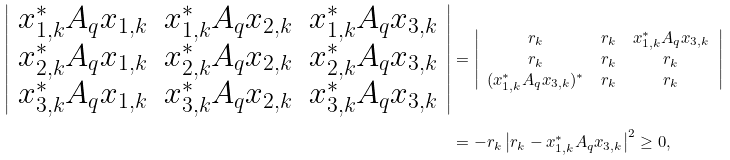<formula> <loc_0><loc_0><loc_500><loc_500>\left | \begin{array} { c c c } x _ { 1 , k } ^ { \ast } A _ { q } x _ { 1 , k } & x _ { 1 , k } ^ { \ast } A _ { q } x _ { 2 , k } & x _ { 1 , k } ^ { \ast } A _ { q } x _ { 3 , k } \\ x _ { 2 , k } ^ { \ast } A _ { q } x _ { 1 , k } & x _ { 2 , k } ^ { \ast } A _ { q } x _ { 2 , k } & x _ { 2 , k } ^ { \ast } A _ { q } x _ { 3 , k } \\ x _ { 3 , k } ^ { \ast } A _ { q } x _ { 1 , k } & x _ { 3 , k } ^ { \ast } A _ { q } x _ { 2 , k } & x _ { 3 , k } ^ { \ast } A _ { q } x _ { 3 , k } \end{array} \right | & = \left | \begin{array} { c c c } r _ { k } & r _ { k } & x _ { 1 , k } ^ { \ast } A _ { q } x _ { 3 , k } \\ r _ { k } & r _ { k } & r _ { k } \\ ( x _ { 1 , k } ^ { \ast } A _ { q } x _ { 3 , k } ) ^ { * } & r _ { k } & r _ { k } \end{array} \right | \\ & = - r _ { k } \left | r _ { k } - x _ { 1 , k } ^ { \ast } A _ { q } x _ { 3 , k } \right | ^ { 2 } \geq 0 ,</formula> 